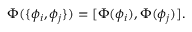<formula> <loc_0><loc_0><loc_500><loc_500>\Phi ( \{ \phi _ { i } , \phi _ { j } \} ) = [ \Phi ( \phi _ { i } ) , \Phi ( \phi _ { j } ) ] .</formula> 